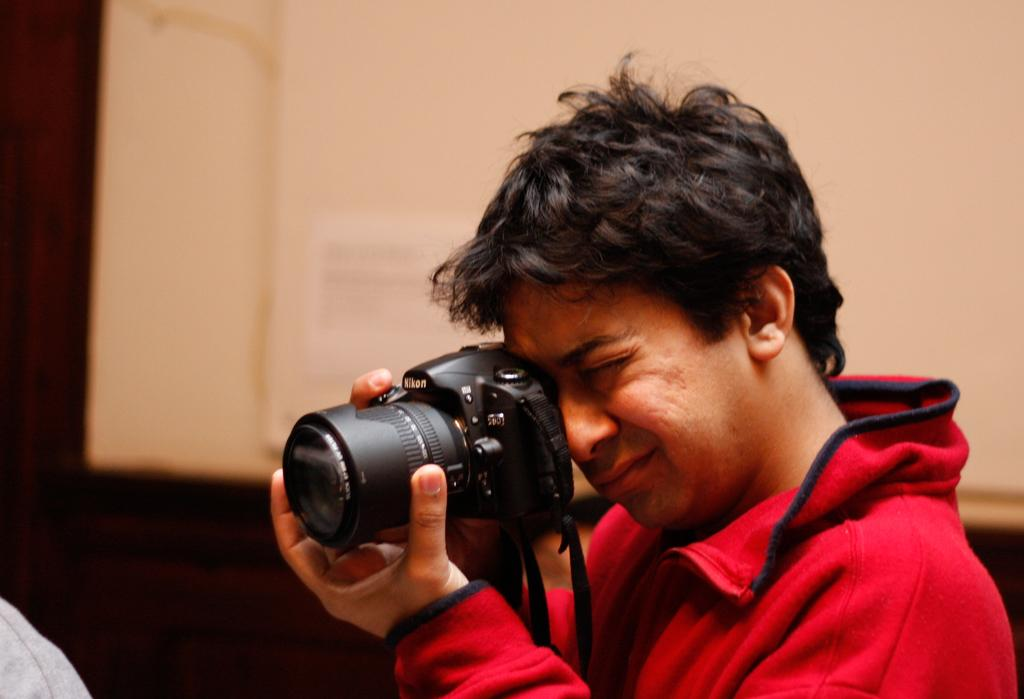Who is the main subject in the image? There is a man in the image. Where is the man located in the image? The man is in the center of the image. What is the man doing in the image? The man is taking a photo. What is the man holding in the image? The man is holding a camera. What type of mass can be seen in the image? There is no mass present in the image; it features a man taking a photo with a camera. What kind of doll is sitting on the man's shoulder in the image? There is no doll present in the image; the man is holding a camera while taking a photo. 